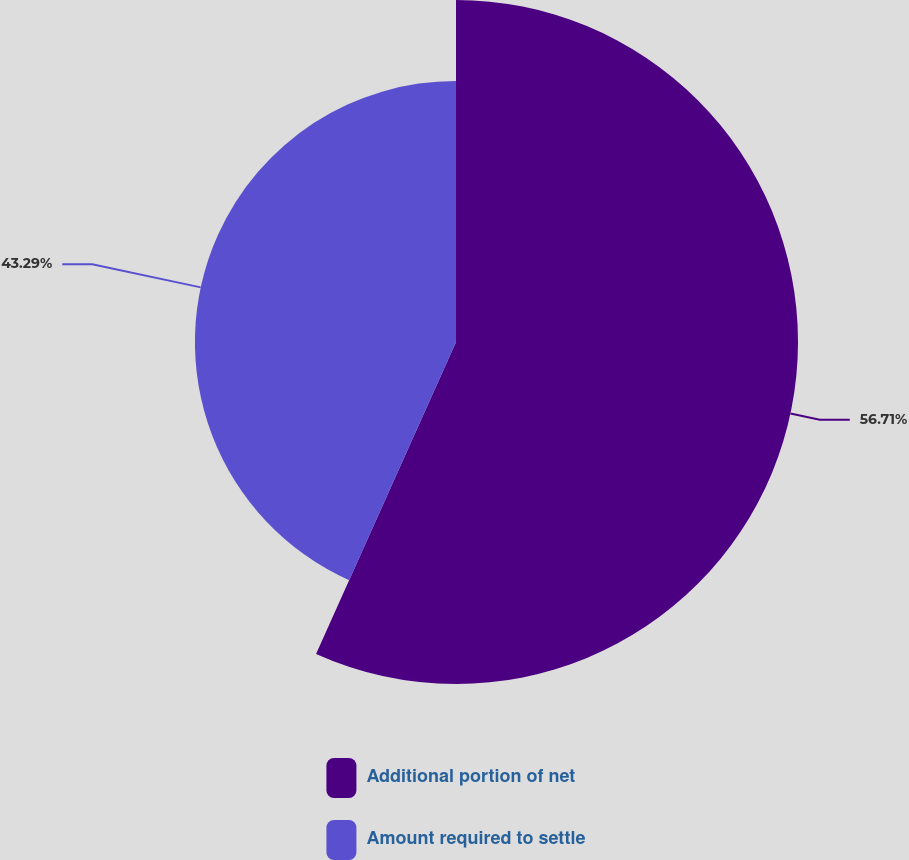Convert chart. <chart><loc_0><loc_0><loc_500><loc_500><pie_chart><fcel>Additional portion of net<fcel>Amount required to settle<nl><fcel>56.71%<fcel>43.29%<nl></chart> 